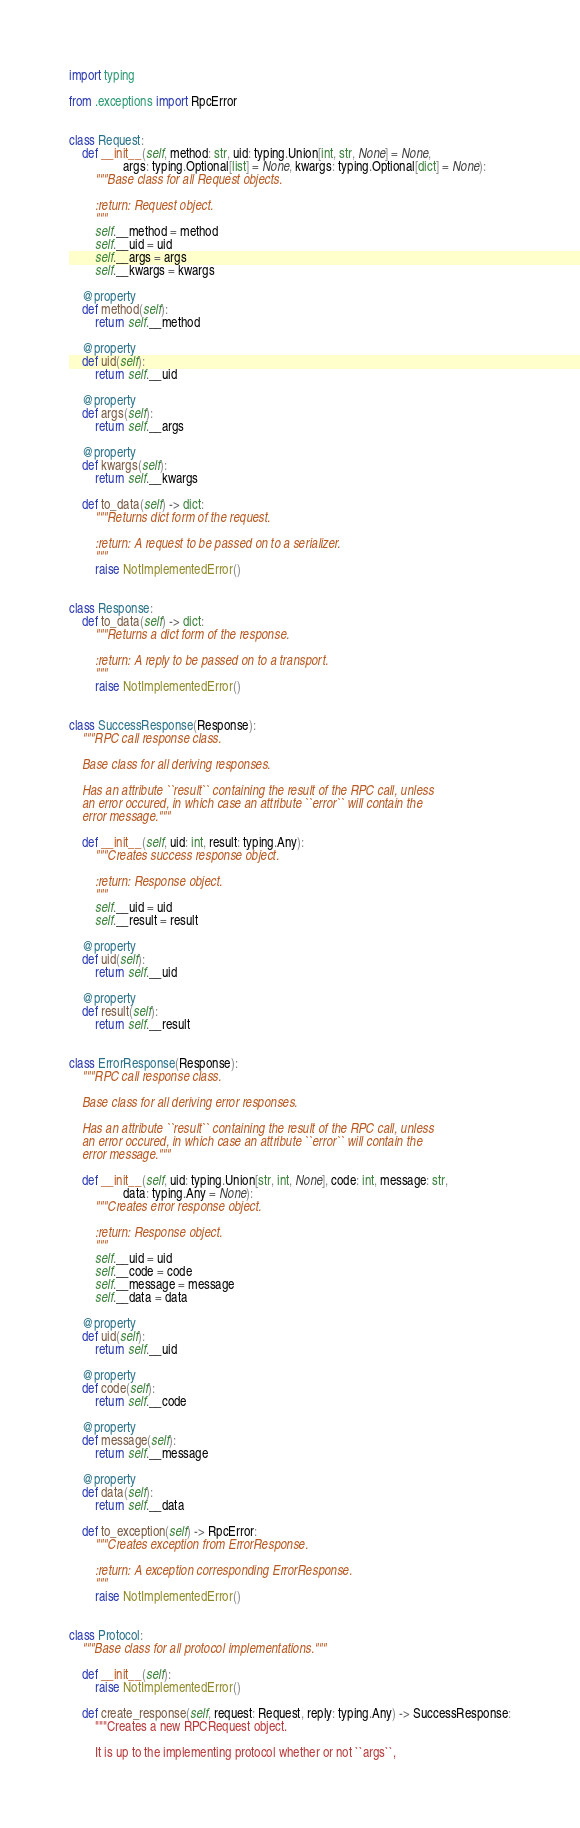<code> <loc_0><loc_0><loc_500><loc_500><_Python_>import typing

from .exceptions import RpcError


class Request:
    def __init__(self, method: str, uid: typing.Union[int, str, None] = None,
                 args: typing.Optional[list] = None, kwargs: typing.Optional[dict] = None):
        """Base class for all Request objects.

        :return: Request object.
        """
        self.__method = method
        self.__uid = uid
        self.__args = args
        self.__kwargs = kwargs

    @property
    def method(self):
        return self.__method

    @property
    def uid(self):
        return self.__uid

    @property
    def args(self):
        return self.__args

    @property
    def kwargs(self):
        return self.__kwargs

    def to_data(self) -> dict:
        """Returns dict form of the request.

        :return: A request to be passed on to a serializer.
        """
        raise NotImplementedError()


class Response:
    def to_data(self) -> dict:
        """Returns a dict form of the response.

        :return: A reply to be passed on to a transport.
        """
        raise NotImplementedError()


class SuccessResponse(Response):
    """RPC call response class.

    Base class for all deriving responses.

    Has an attribute ``result`` containing the result of the RPC call, unless
    an error occured, in which case an attribute ``error`` will contain the
    error message."""

    def __init__(self, uid: int, result: typing.Any):
        """Creates success response object.

        :return: Response object.
        """
        self.__uid = uid
        self.__result = result

    @property
    def uid(self):
        return self.__uid

    @property
    def result(self):
        return self.__result


class ErrorResponse(Response):
    """RPC call response class.

    Base class for all deriving error responses.

    Has an attribute ``result`` containing the result of the RPC call, unless
    an error occured, in which case an attribute ``error`` will contain the
    error message."""

    def __init__(self, uid: typing.Union[str, int, None], code: int, message: str,
                 data: typing.Any = None):
        """Creates error response object.

        :return: Response object.
        """
        self.__uid = uid
        self.__code = code
        self.__message = message
        self.__data = data

    @property
    def uid(self):
        return self.__uid

    @property
    def code(self):
        return self.__code

    @property
    def message(self):
        return self.__message

    @property
    def data(self):
        return self.__data

    def to_exception(self) -> RpcError:
        """Creates exception from ErrorResponse.

        :return: A exception corresponding ErrorResponse.
        """
        raise NotImplementedError()


class Protocol:
    """Base class for all protocol implementations."""

    def __init__(self):
        raise NotImplementedError()

    def create_response(self, request: Request, reply: typing.Any) -> SuccessResponse:
        """Creates a new RPCRequest object.

        It is up to the implementing protocol whether or not ``args``,</code> 